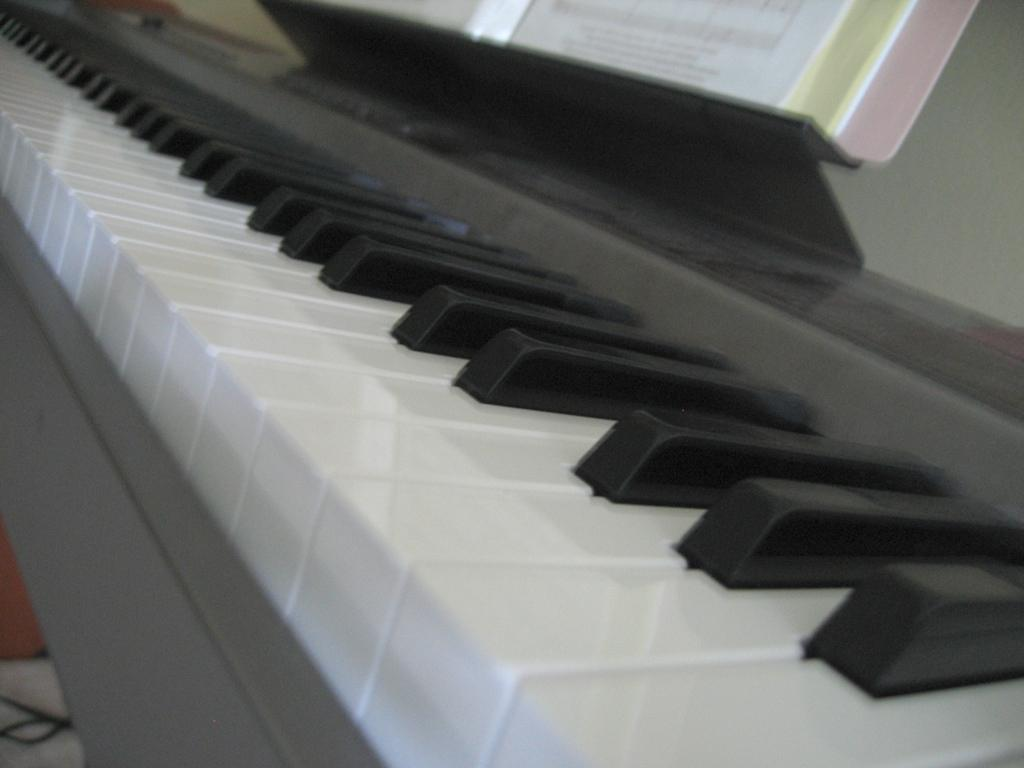What is the main object in the image? There is a piano in the image. What is placed in front of the piano? There is a book in front of the piano. What type of humor can be found in the book on the piano? There is no indication of the book's content in the image, so it cannot be determined if it contains humor. 